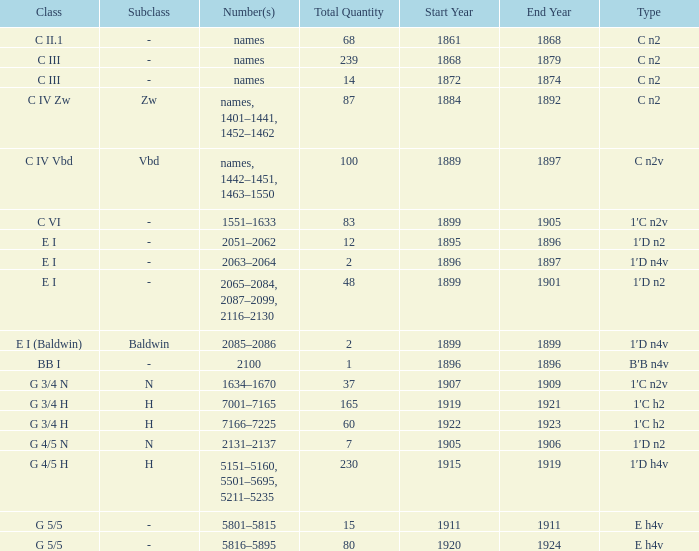Which Quantity has a Type of e h4v, and a Year(s) of Manufacture of 1920–1924? 80.0. 